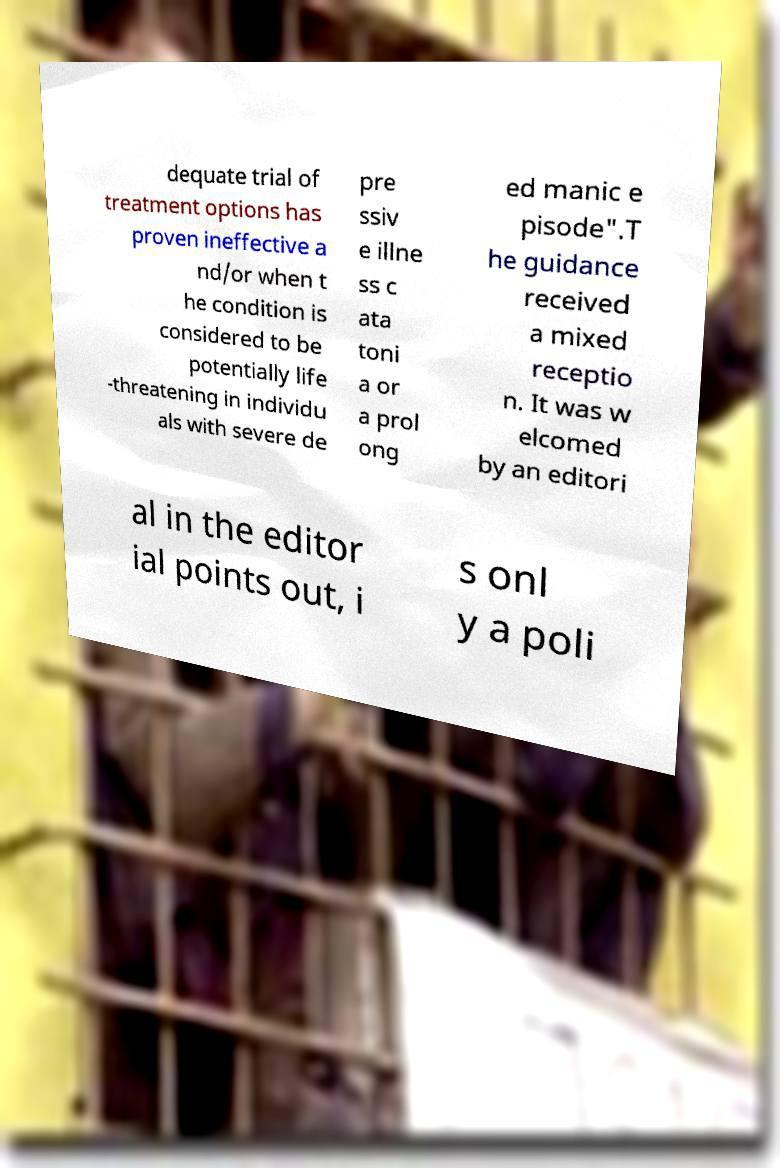For documentation purposes, I need the text within this image transcribed. Could you provide that? dequate trial of treatment options has proven ineffective a nd/or when t he condition is considered to be potentially life -threatening in individu als with severe de pre ssiv e illne ss c ata toni a or a prol ong ed manic e pisode".T he guidance received a mixed receptio n. It was w elcomed by an editori al in the editor ial points out, i s onl y a poli 